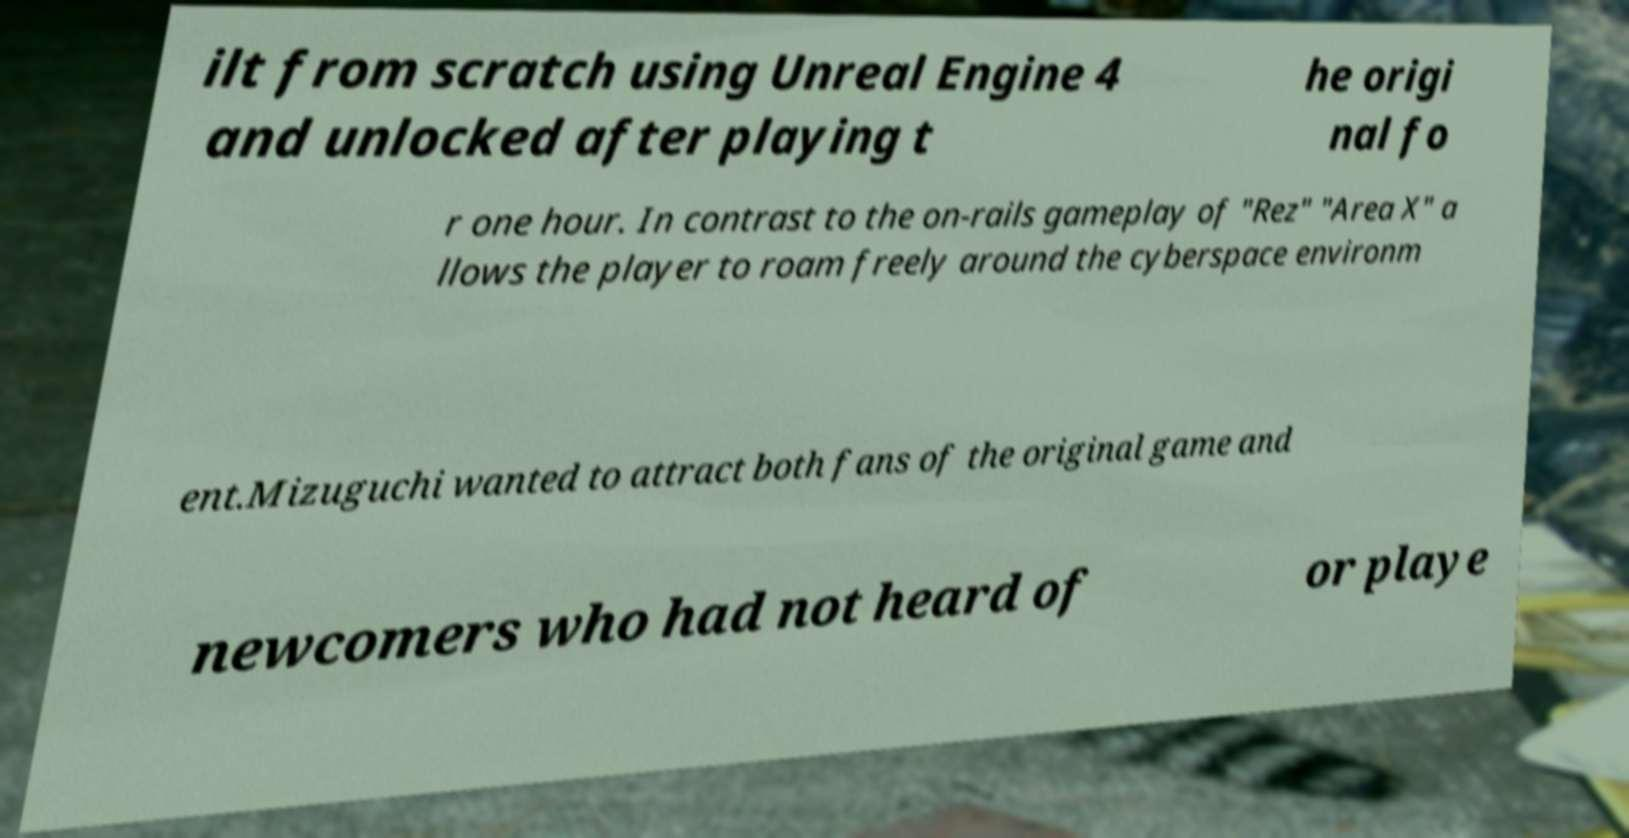For documentation purposes, I need the text within this image transcribed. Could you provide that? ilt from scratch using Unreal Engine 4 and unlocked after playing t he origi nal fo r one hour. In contrast to the on-rails gameplay of "Rez" "Area X" a llows the player to roam freely around the cyberspace environm ent.Mizuguchi wanted to attract both fans of the original game and newcomers who had not heard of or playe 